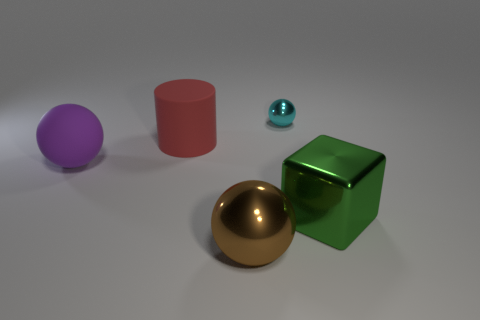What shape is the green thing that is made of the same material as the big brown object?
Your answer should be compact. Cube. How big is the ball that is to the right of the metal sphere in front of the large green metal block?
Keep it short and to the point. Small. The big purple thing is what shape?
Keep it short and to the point. Sphere. What number of big objects are either matte balls or green things?
Your answer should be very brief. 2. The purple matte thing that is the same shape as the tiny cyan metallic object is what size?
Offer a terse response. Large. How many large objects are on the left side of the green shiny block and in front of the large matte ball?
Make the answer very short. 1. There is a cyan shiny object; is its shape the same as the large thing on the right side of the big brown thing?
Make the answer very short. No. Is the number of tiny shiny things that are to the left of the metallic block greater than the number of small cyan metallic balls?
Give a very brief answer. No. Is the number of tiny cyan things right of the tiny cyan shiny ball less than the number of small brown metal cylinders?
Make the answer very short. No. What number of big cubes are the same color as the small metal thing?
Your answer should be compact. 0. 